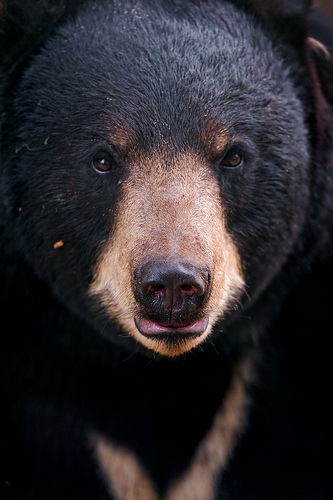If this bear was to attend a bear council meeting, what issues might it bring up? At the bear council meeting, this bear might raise concerns about habitat destruction due to logging activities. It would advocate for the preservation of ancient trees that are crucial for hibernation. Another issue could be the pollution of rivers and streams, which affects the availability of fish, essential to their diet. The bear might also discuss the increased human encroachment into natural habitats, proposing strategies to ensure the safety and sustainability of their living environments. What solutions could the bear council propose to address these issues? The bear council could propose creating protected areas where logging is prohibited and working with conservationists to reforest areas that have been affected. To address water pollution, initiatives to clean and monitor water bodies could be put in place, and advocating for stricter regulations on industrial waste management. Regarding human encroachment, they might push for more awareness campaigns, promoting coexistence and the importance of natural habitats. The council could also foster partnerships with local communities to develop eco-friendly tourism, ensuring economic benefits without compromising the environment. 